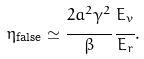<formula> <loc_0><loc_0><loc_500><loc_500>\eta _ { \text {false} } \simeq \cfrac { 2 a ^ { 2 } \gamma ^ { 2 } } { \beta } \, \cfrac { E _ { v } } { E _ { r } } .</formula> 